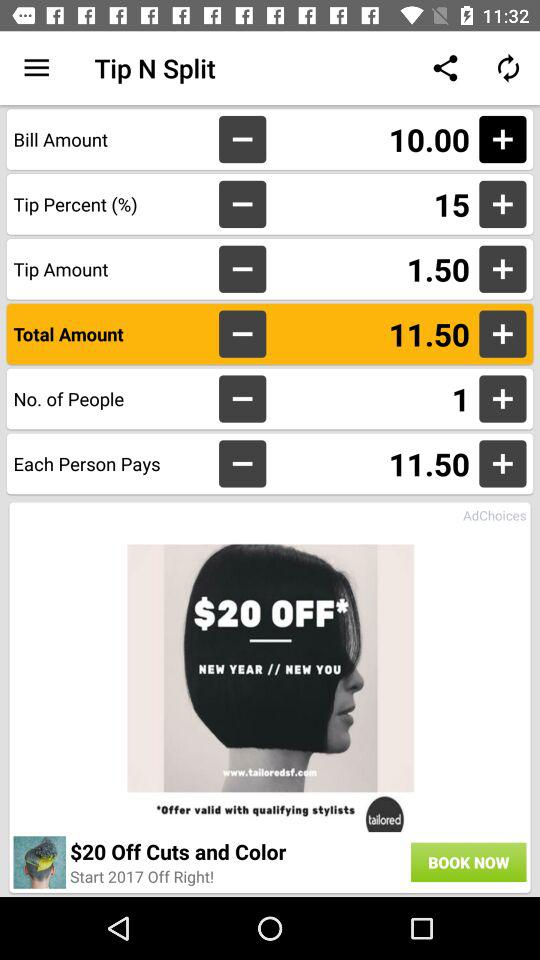What is the number of people? The number of people is 1. 